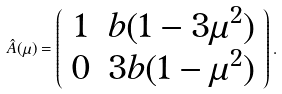Convert formula to latex. <formula><loc_0><loc_0><loc_500><loc_500>\hat { A } ( \mu ) = \left ( \begin{array} { c c } 1 & b ( 1 - 3 \mu ^ { 2 } ) \\ 0 & 3 b ( 1 - \mu ^ { 2 } ) \\ \end{array} \right ) .</formula> 